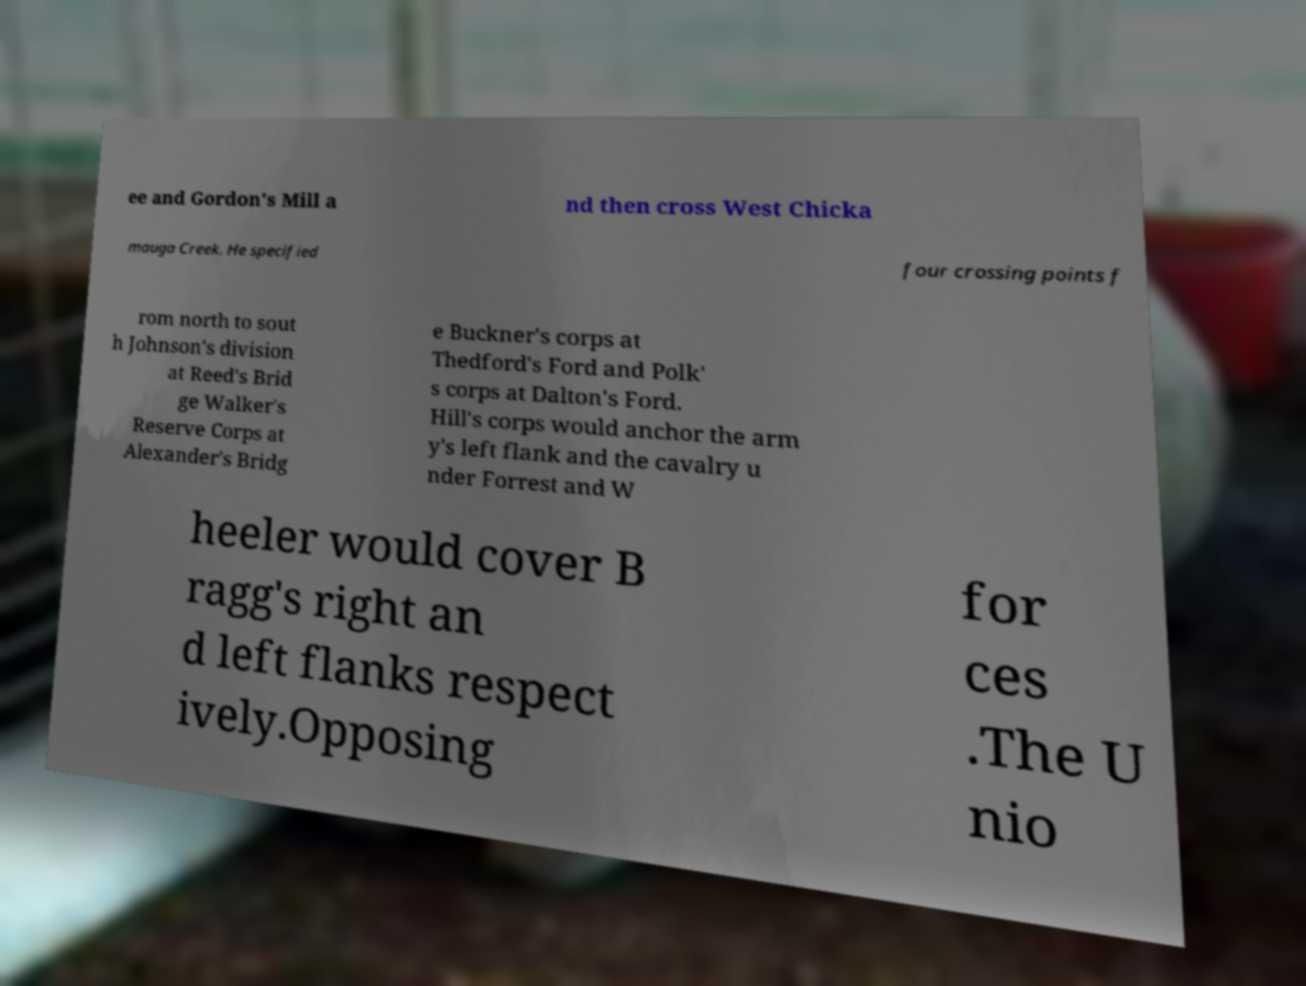What messages or text are displayed in this image? I need them in a readable, typed format. ee and Gordon's Mill a nd then cross West Chicka mauga Creek. He specified four crossing points f rom north to sout h Johnson's division at Reed's Brid ge Walker's Reserve Corps at Alexander's Bridg e Buckner's corps at Thedford's Ford and Polk' s corps at Dalton's Ford. Hill's corps would anchor the arm y's left flank and the cavalry u nder Forrest and W heeler would cover B ragg's right an d left flanks respect ively.Opposing for ces .The U nio 